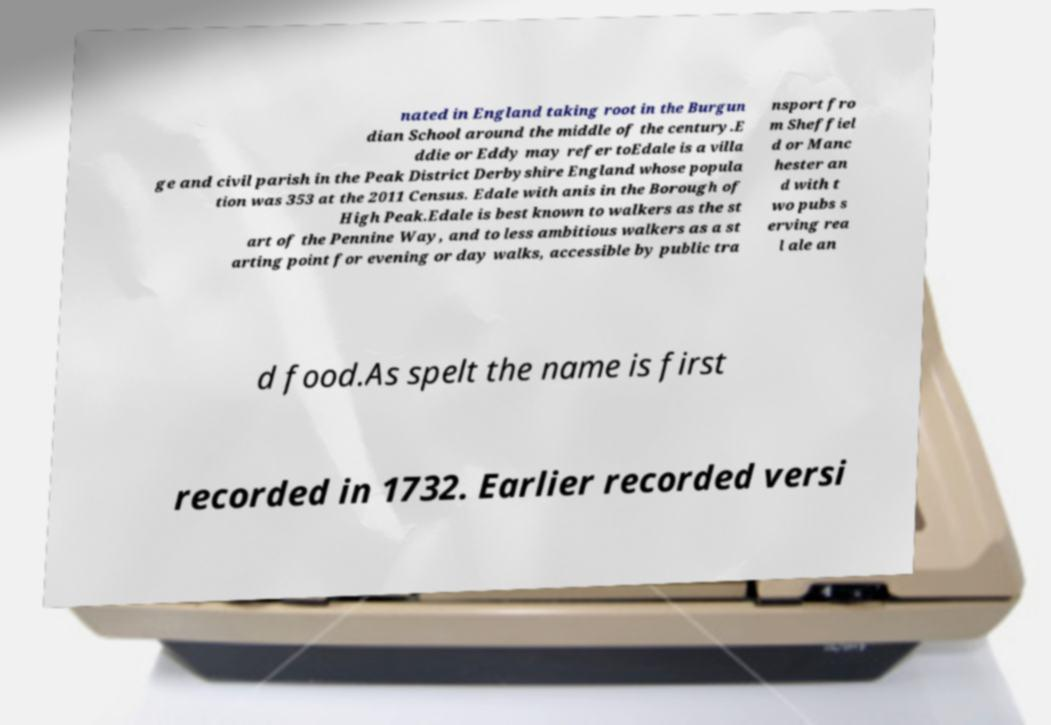I need the written content from this picture converted into text. Can you do that? nated in England taking root in the Burgun dian School around the middle of the century.E ddie or Eddy may refer toEdale is a villa ge and civil parish in the Peak District Derbyshire England whose popula tion was 353 at the 2011 Census. Edale with anis in the Borough of High Peak.Edale is best known to walkers as the st art of the Pennine Way, and to less ambitious walkers as a st arting point for evening or day walks, accessible by public tra nsport fro m Sheffiel d or Manc hester an d with t wo pubs s erving rea l ale an d food.As spelt the name is first recorded in 1732. Earlier recorded versi 